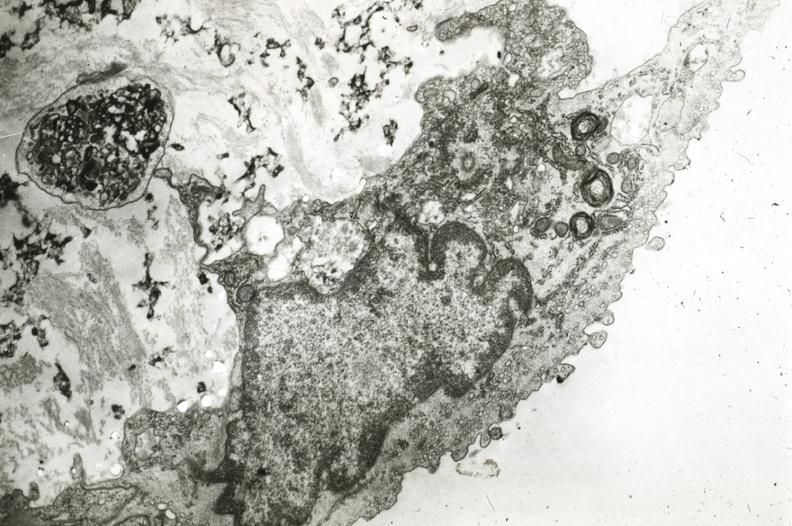s vasculature present?
Answer the question using a single word or phrase. Yes 